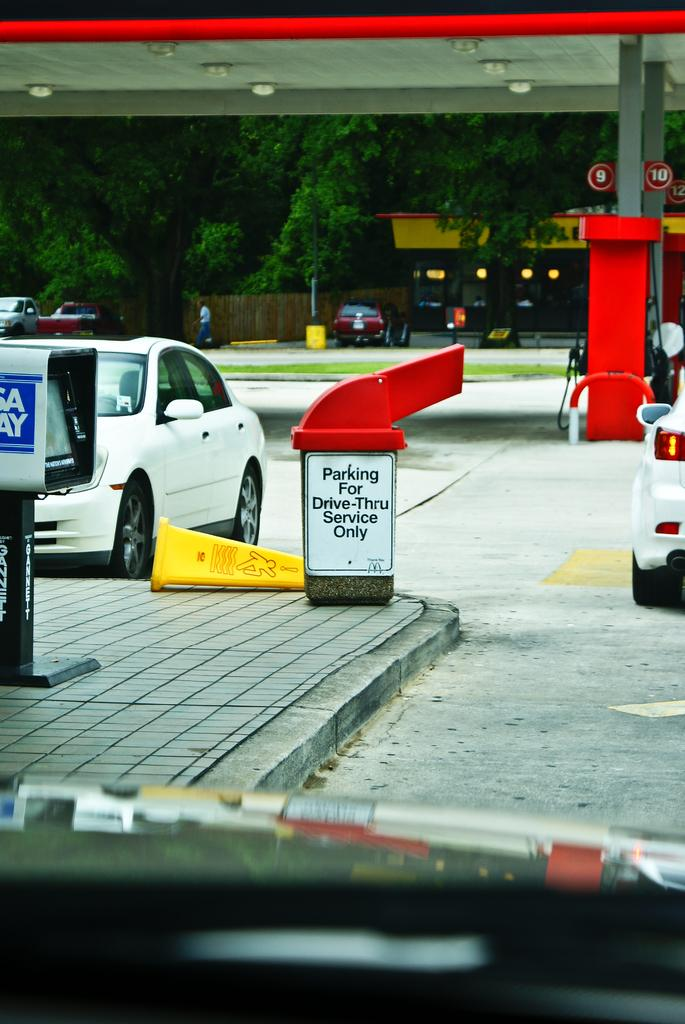Provide a one-sentence caption for the provided image. Sign on a dumpster that says "Parking For Drive-Thru Service Only". 